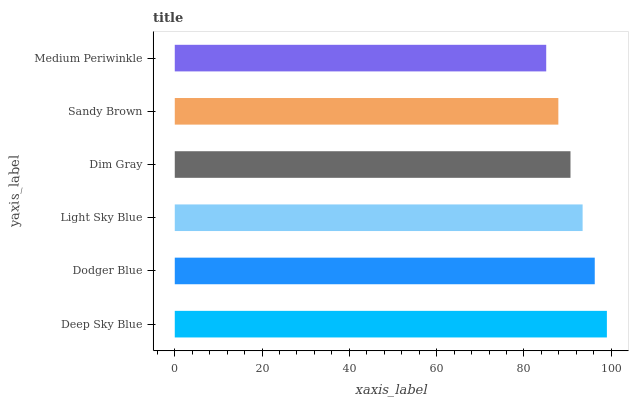Is Medium Periwinkle the minimum?
Answer yes or no. Yes. Is Deep Sky Blue the maximum?
Answer yes or no. Yes. Is Dodger Blue the minimum?
Answer yes or no. No. Is Dodger Blue the maximum?
Answer yes or no. No. Is Deep Sky Blue greater than Dodger Blue?
Answer yes or no. Yes. Is Dodger Blue less than Deep Sky Blue?
Answer yes or no. Yes. Is Dodger Blue greater than Deep Sky Blue?
Answer yes or no. No. Is Deep Sky Blue less than Dodger Blue?
Answer yes or no. No. Is Light Sky Blue the high median?
Answer yes or no. Yes. Is Dim Gray the low median?
Answer yes or no. Yes. Is Dodger Blue the high median?
Answer yes or no. No. Is Light Sky Blue the low median?
Answer yes or no. No. 